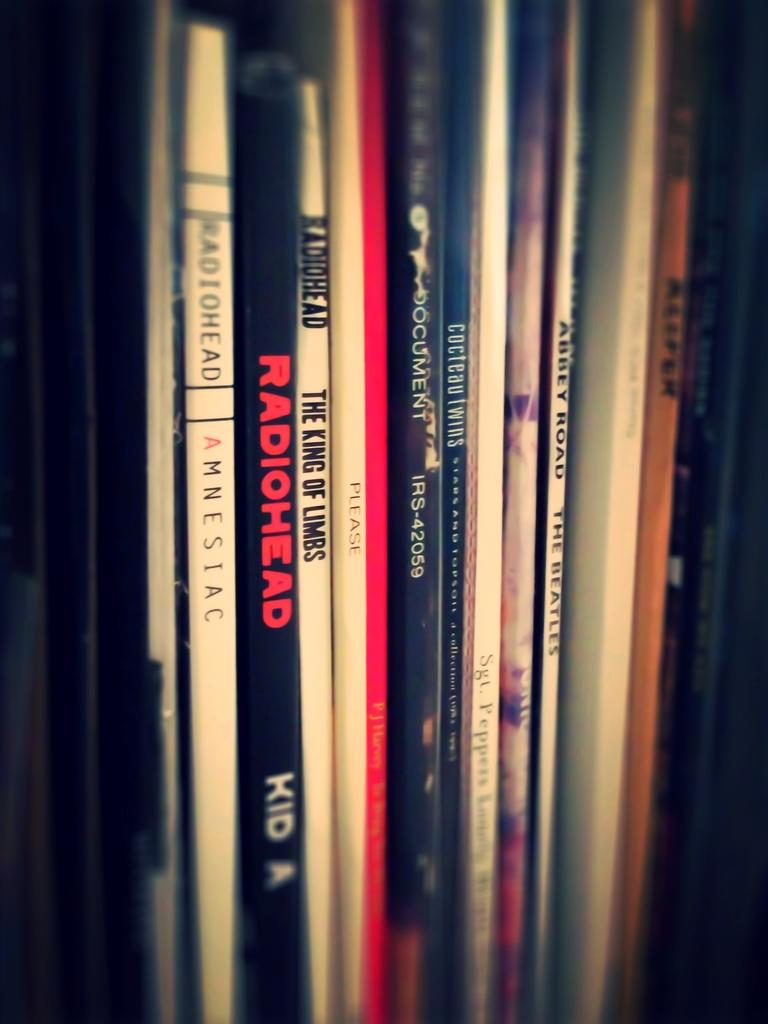<image>
Create a compact narrative representing the image presented. the word radiohead that is on a book 